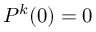Convert formula to latex. <formula><loc_0><loc_0><loc_500><loc_500>P ^ { k } ( 0 ) = 0</formula> 